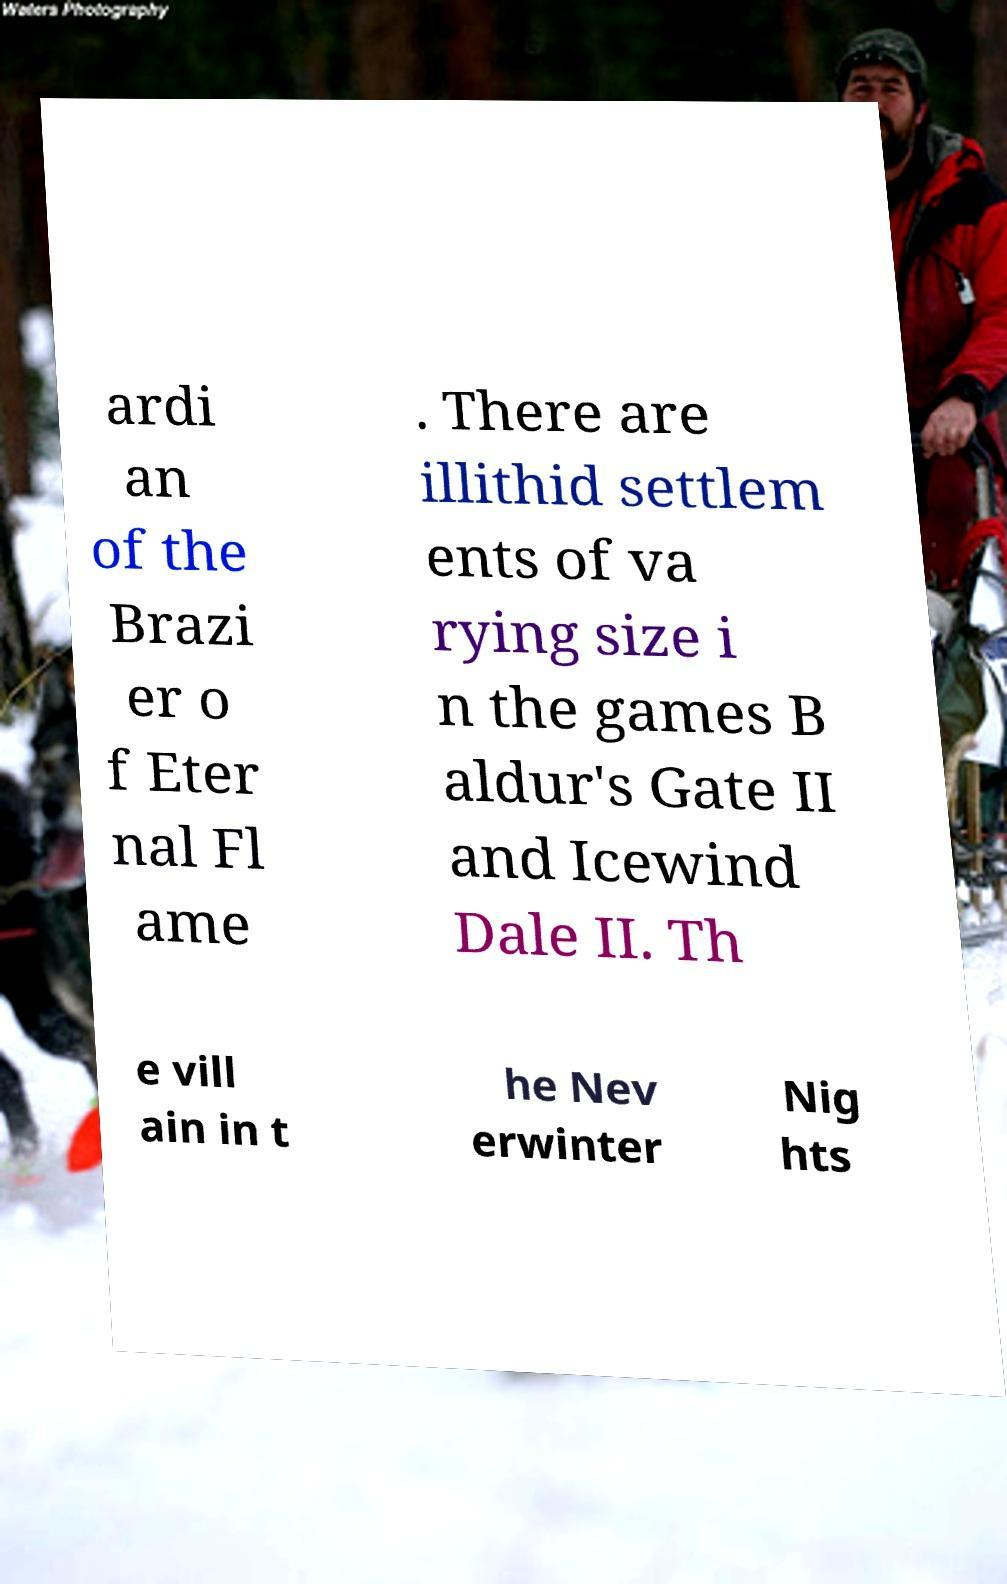I need the written content from this picture converted into text. Can you do that? ardi an of the Brazi er o f Eter nal Fl ame . There are illithid settlem ents of va rying size i n the games B aldur's Gate II and Icewind Dale II. Th e vill ain in t he Nev erwinter Nig hts 